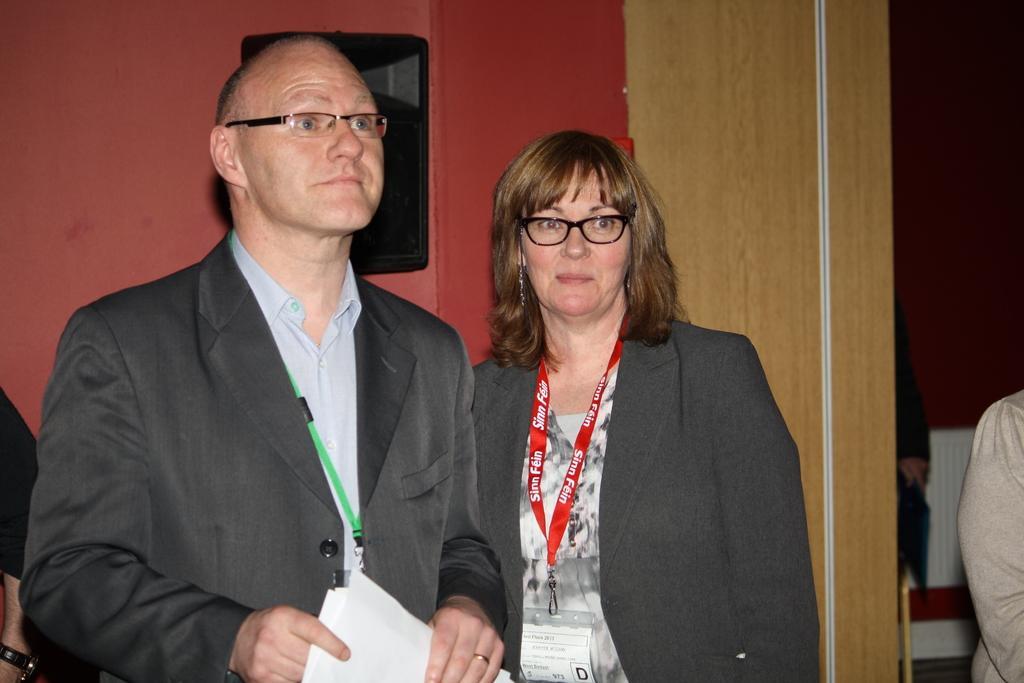Can you describe this image briefly? In this image there is one man and one woman standing and man is holding some papers, and also in the background there are some people wall and some object on the wall. And on the right side of the image there are chairs. 